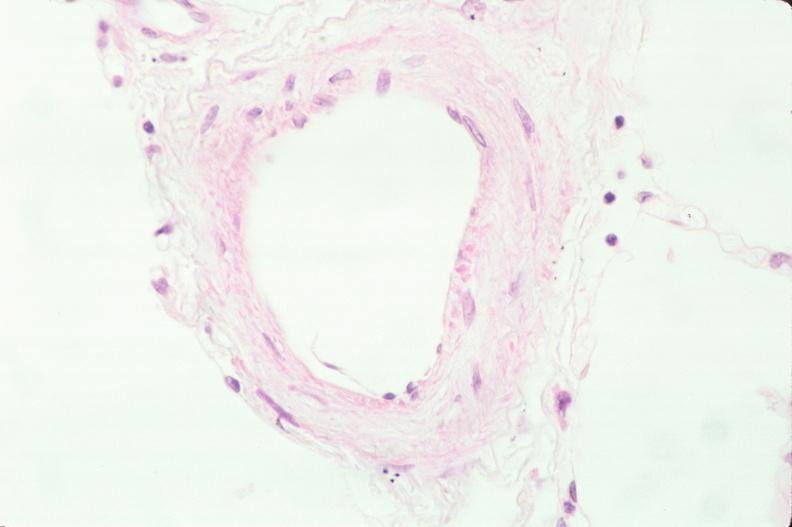what does this image show?
Answer the question using a single word or phrase. Lung 